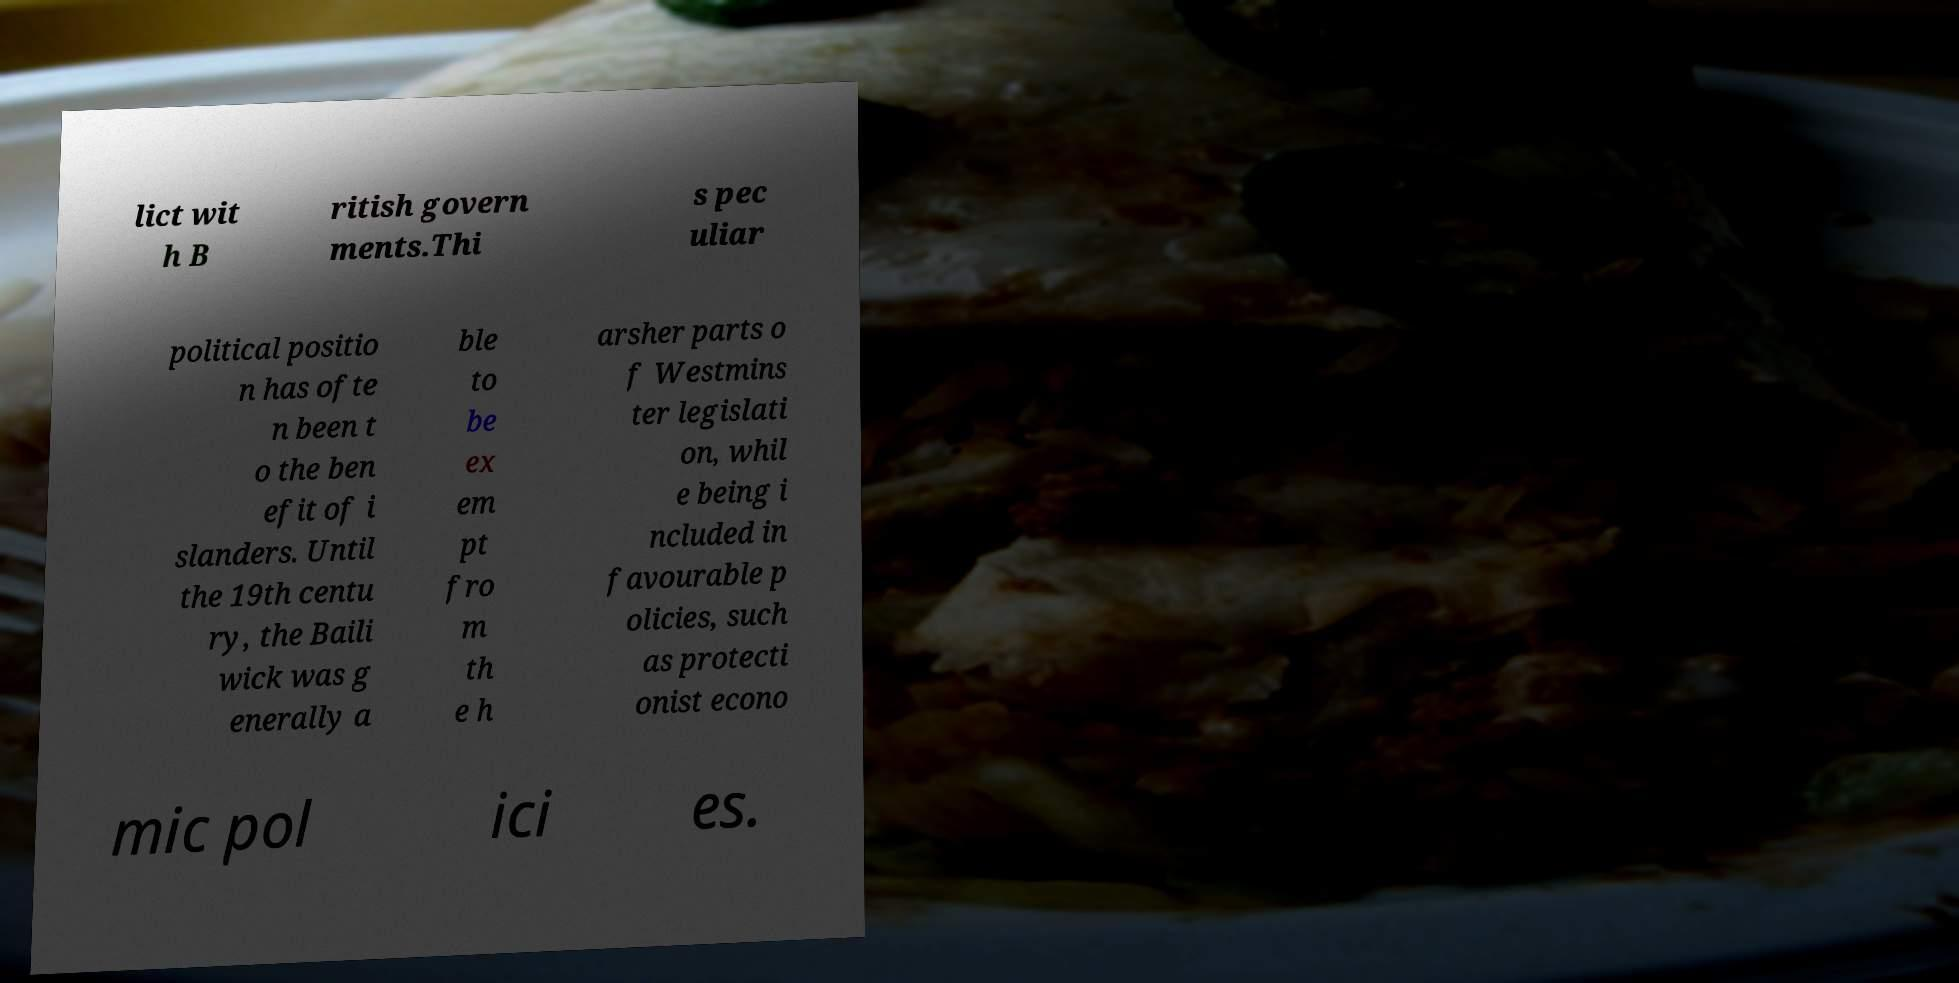Please read and relay the text visible in this image. What does it say? lict wit h B ritish govern ments.Thi s pec uliar political positio n has ofte n been t o the ben efit of i slanders. Until the 19th centu ry, the Baili wick was g enerally a ble to be ex em pt fro m th e h arsher parts o f Westmins ter legislati on, whil e being i ncluded in favourable p olicies, such as protecti onist econo mic pol ici es. 